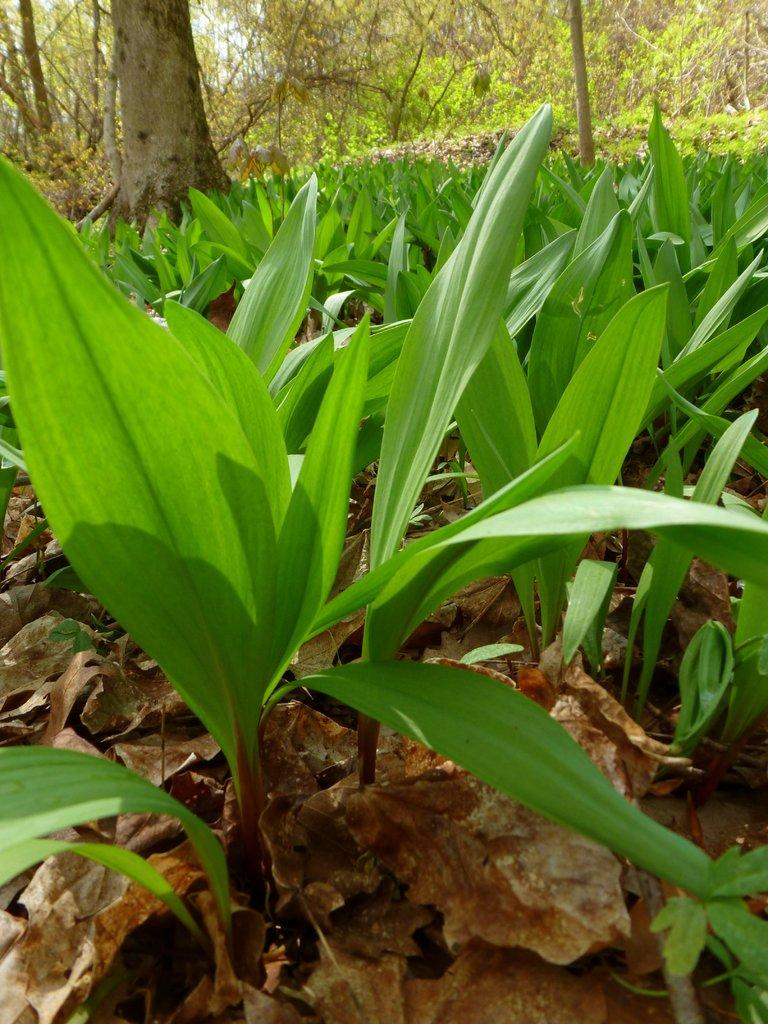What type of vegetation can be seen in the image? There are plants and trees in the image. Can you describe the ground in the image? Dried leaves are leaves are present on the ground in the image. What type of harmony can be heard in the image? There is no sound or music present in the image, so it is not possible to determine any harmony. 